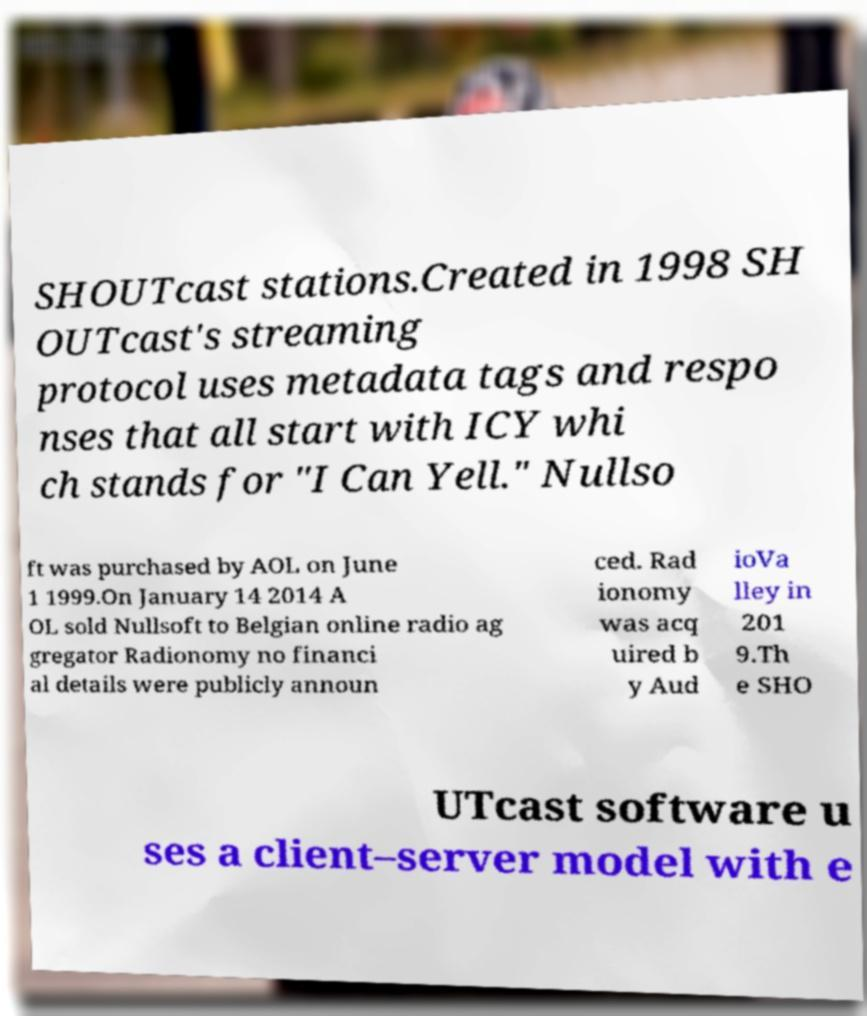I need the written content from this picture converted into text. Can you do that? SHOUTcast stations.Created in 1998 SH OUTcast's streaming protocol uses metadata tags and respo nses that all start with ICY whi ch stands for "I Can Yell." Nullso ft was purchased by AOL on June 1 1999.On January 14 2014 A OL sold Nullsoft to Belgian online radio ag gregator Radionomy no financi al details were publicly announ ced. Rad ionomy was acq uired b y Aud ioVa lley in 201 9.Th e SHO UTcast software u ses a client–server model with e 